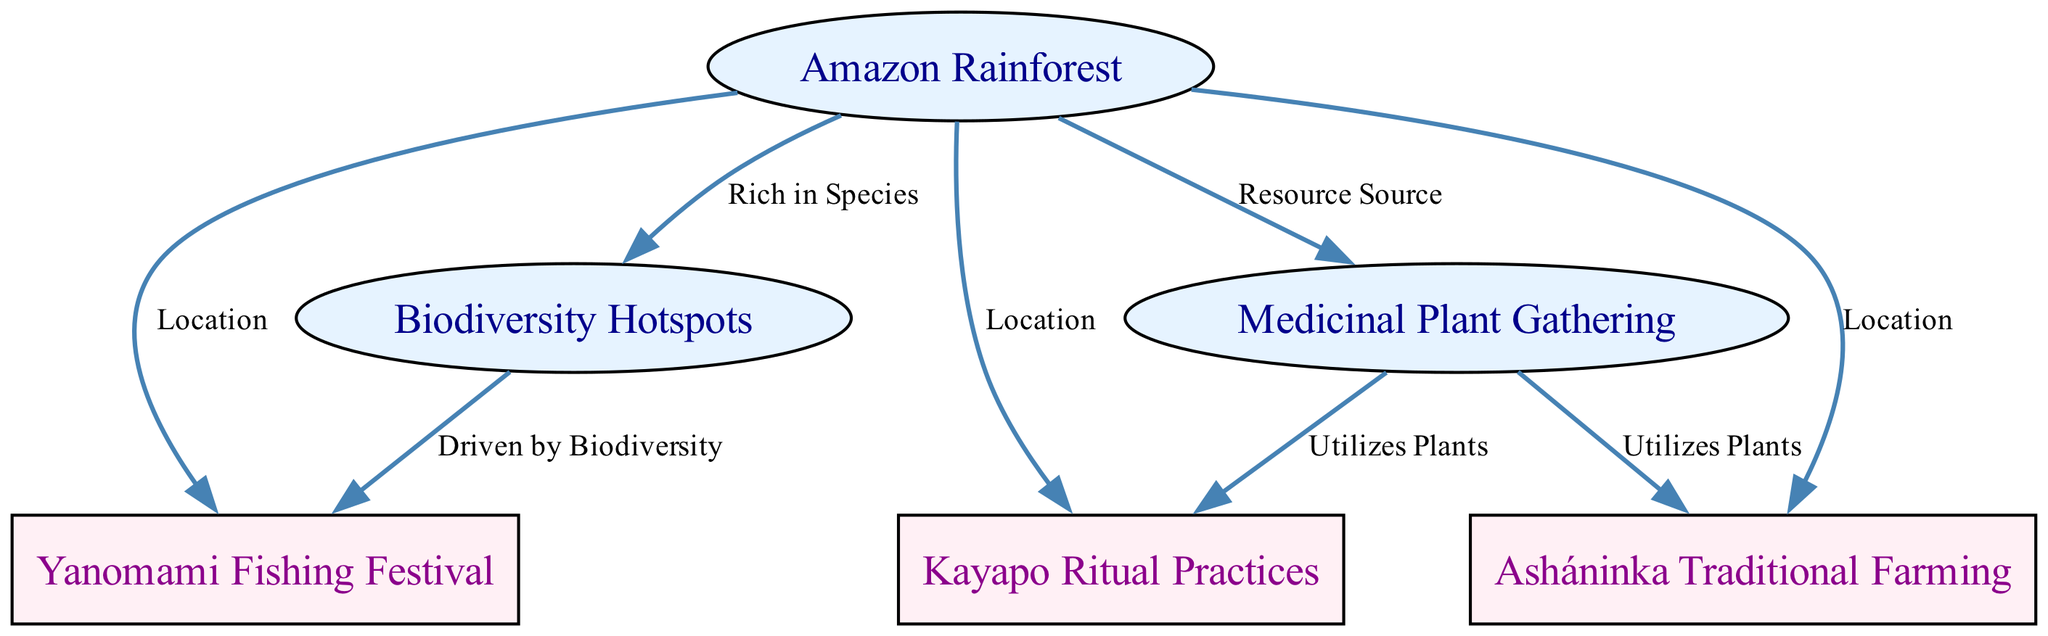What is the main ecological region represented in the diagram? The diagram highlights the Amazon Rainforest as the central ecological region, indicated by the node labeled "Amazon Rainforest."
Answer: Amazon Rainforest How many cultural activities are represented in the diagram? There are three cultural activities represented in the diagram: "Yanomami Fishing Festival," "Kayapo Ritual Practices," and "Asháninka Traditional Farming." Each activity is shown as a separate node, totaling three.
Answer: 3 What ecological resource is associated with the Yanomami Fishing Festival? The Yanomami Fishing Festival is linked to the "Biodiversity Hotspots" node, showing that the activity is driven by biodiversity in the forest, as marked by the edge labeled "Driven by Biodiversity."
Answer: Biodiversity Hotspots Which cultural activity utilizes medicinal plants? The cultural activity that utilizes plants is the "Kayapo Ritual Practices," as indicated by the connection to the node "Medicinal Plant Gathering" with the label "Utilizes Plants."
Answer: Kayapo Ritual Practices What is the relationship between the Amazon Rainforest and traditional farming? The relationship is that the Amazon Rainforest serves as the location for "Asháninka Traditional Farming," which is directly connected to the forest node.
Answer: Location How many total edges are there in the diagram? The diagram contains seven edges, which represent the connections between the various nodes and their relationships as labeled in the diagram.
Answer: 7 Which cultural activity is driven by the biodiversity of the Amazon Rainforest? The cultural activity driven by this biodiversity is the "Yanomami Fishing Festival," as shown by the edge connecting it to the "Biodiversity Hotspots" node with the label "Driven by Biodiversity."
Answer: Yanomami Fishing Festival Which ecological resource serves as a source for traditional farming practices? The ecological resource that serves as a source for traditional farming practices is "Medicinal Plant Gathering," indicating the relevance of plants in the activities.
Answer: Medicinal Plant Gathering 